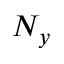<formula> <loc_0><loc_0><loc_500><loc_500>N _ { y }</formula> 